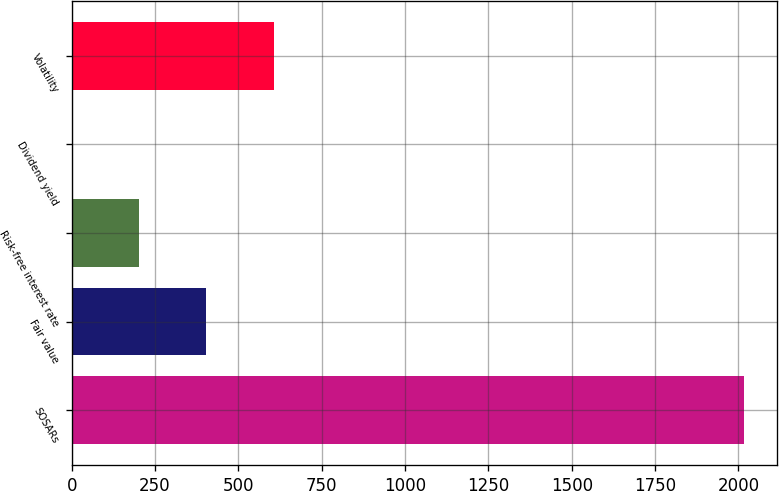Convert chart to OTSL. <chart><loc_0><loc_0><loc_500><loc_500><bar_chart><fcel>SOSARs<fcel>Fair value<fcel>Risk-free interest rate<fcel>Dividend yield<fcel>Volatility<nl><fcel>2016<fcel>404.31<fcel>202.85<fcel>1.39<fcel>605.77<nl></chart> 